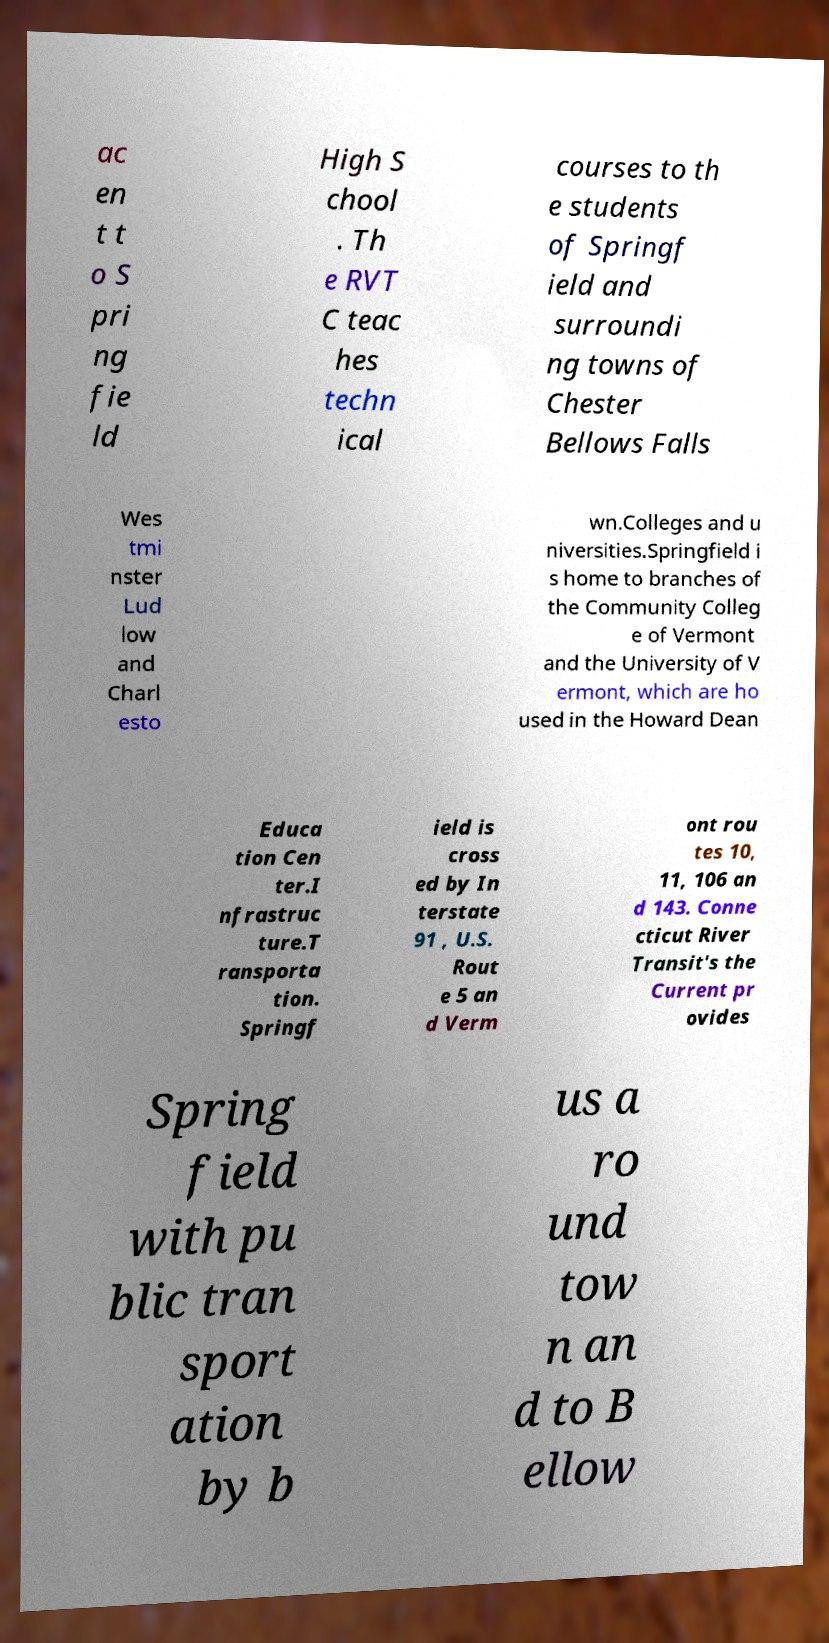Please identify and transcribe the text found in this image. ac en t t o S pri ng fie ld High S chool . Th e RVT C teac hes techn ical courses to th e students of Springf ield and surroundi ng towns of Chester Bellows Falls Wes tmi nster Lud low and Charl esto wn.Colleges and u niversities.Springfield i s home to branches of the Community Colleg e of Vermont and the University of V ermont, which are ho used in the Howard Dean Educa tion Cen ter.I nfrastruc ture.T ransporta tion. Springf ield is cross ed by In terstate 91 , U.S. Rout e 5 an d Verm ont rou tes 10, 11, 106 an d 143. Conne cticut River Transit's the Current pr ovides Spring field with pu blic tran sport ation by b us a ro und tow n an d to B ellow 